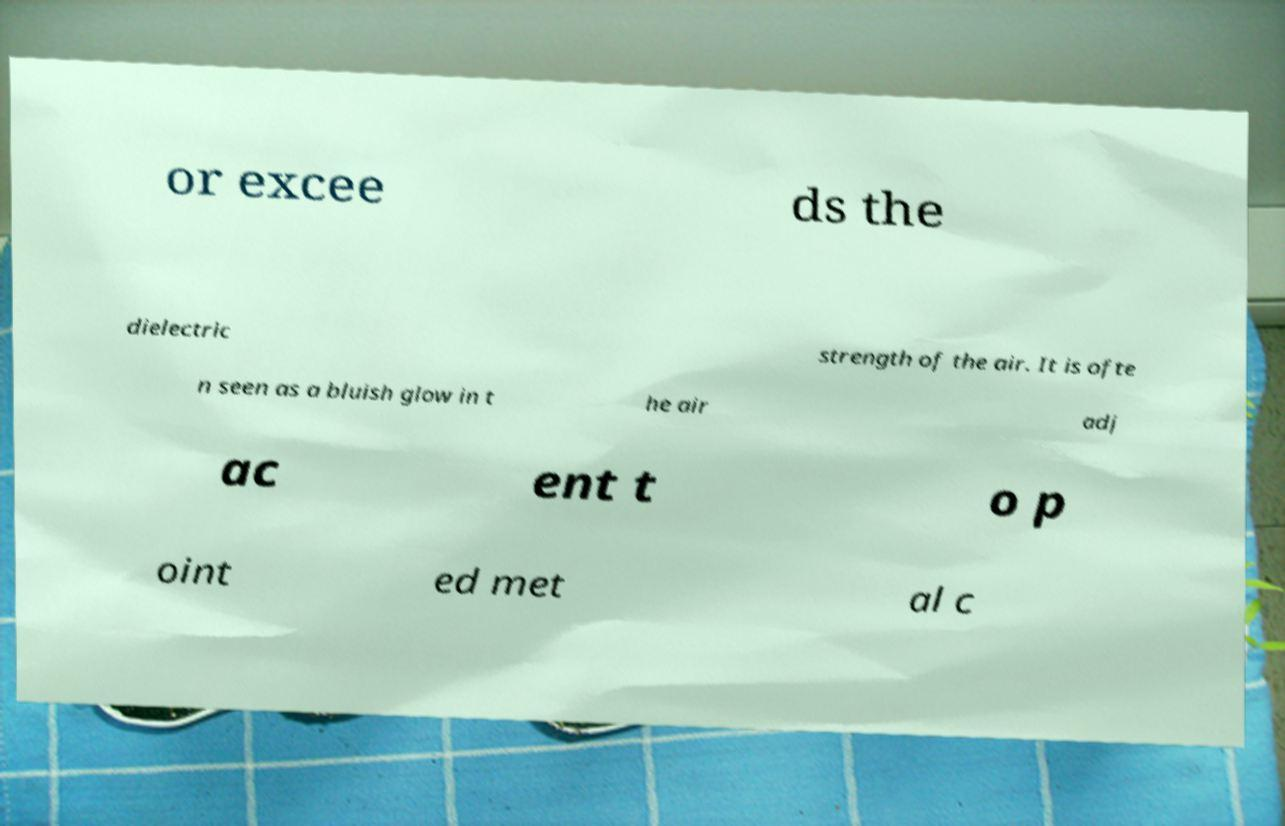Can you accurately transcribe the text from the provided image for me? or excee ds the dielectric strength of the air. It is ofte n seen as a bluish glow in t he air adj ac ent t o p oint ed met al c 